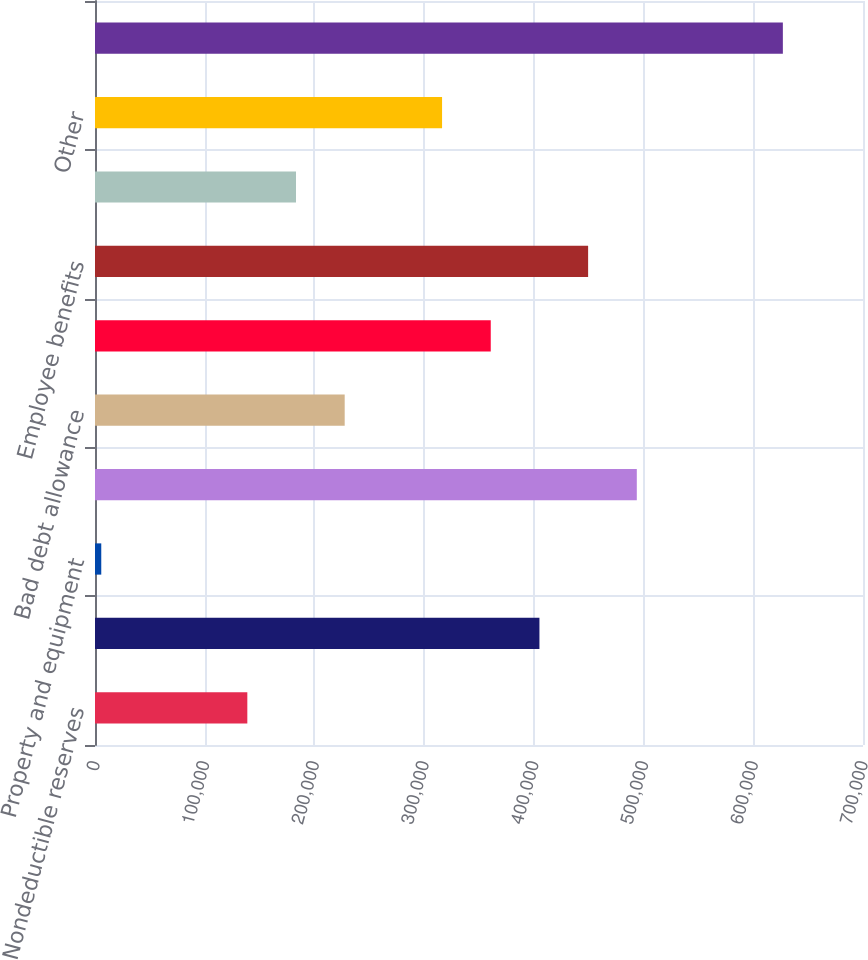Convert chart. <chart><loc_0><loc_0><loc_500><loc_500><bar_chart><fcel>Nondeductible reserves<fcel>Inventory<fcel>Property and equipment<fcel>Intangibles<fcel>Bad debt allowance<fcel>Accrued expenses<fcel>Employee benefits<fcel>Net operating loss and other<fcel>Other<fcel>Gross deferred tax assets<nl><fcel>138834<fcel>405083<fcel>5710<fcel>493833<fcel>227584<fcel>360708<fcel>449458<fcel>183209<fcel>316334<fcel>626957<nl></chart> 